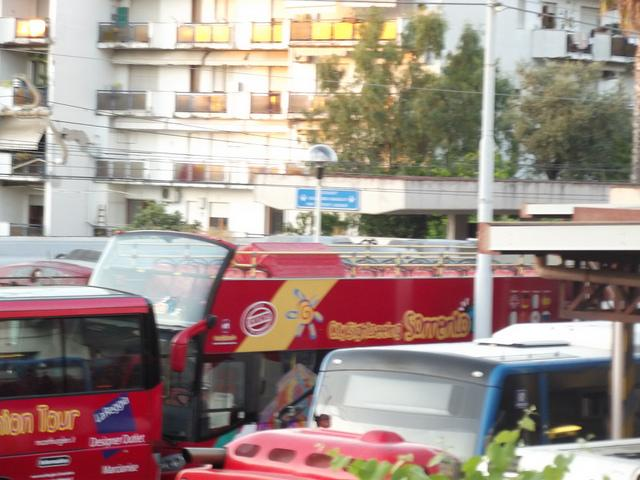What would someone be riding on top of the red bus for?

Choices:
A) tours
B) sleeping
C) shooting
D) eating tours 